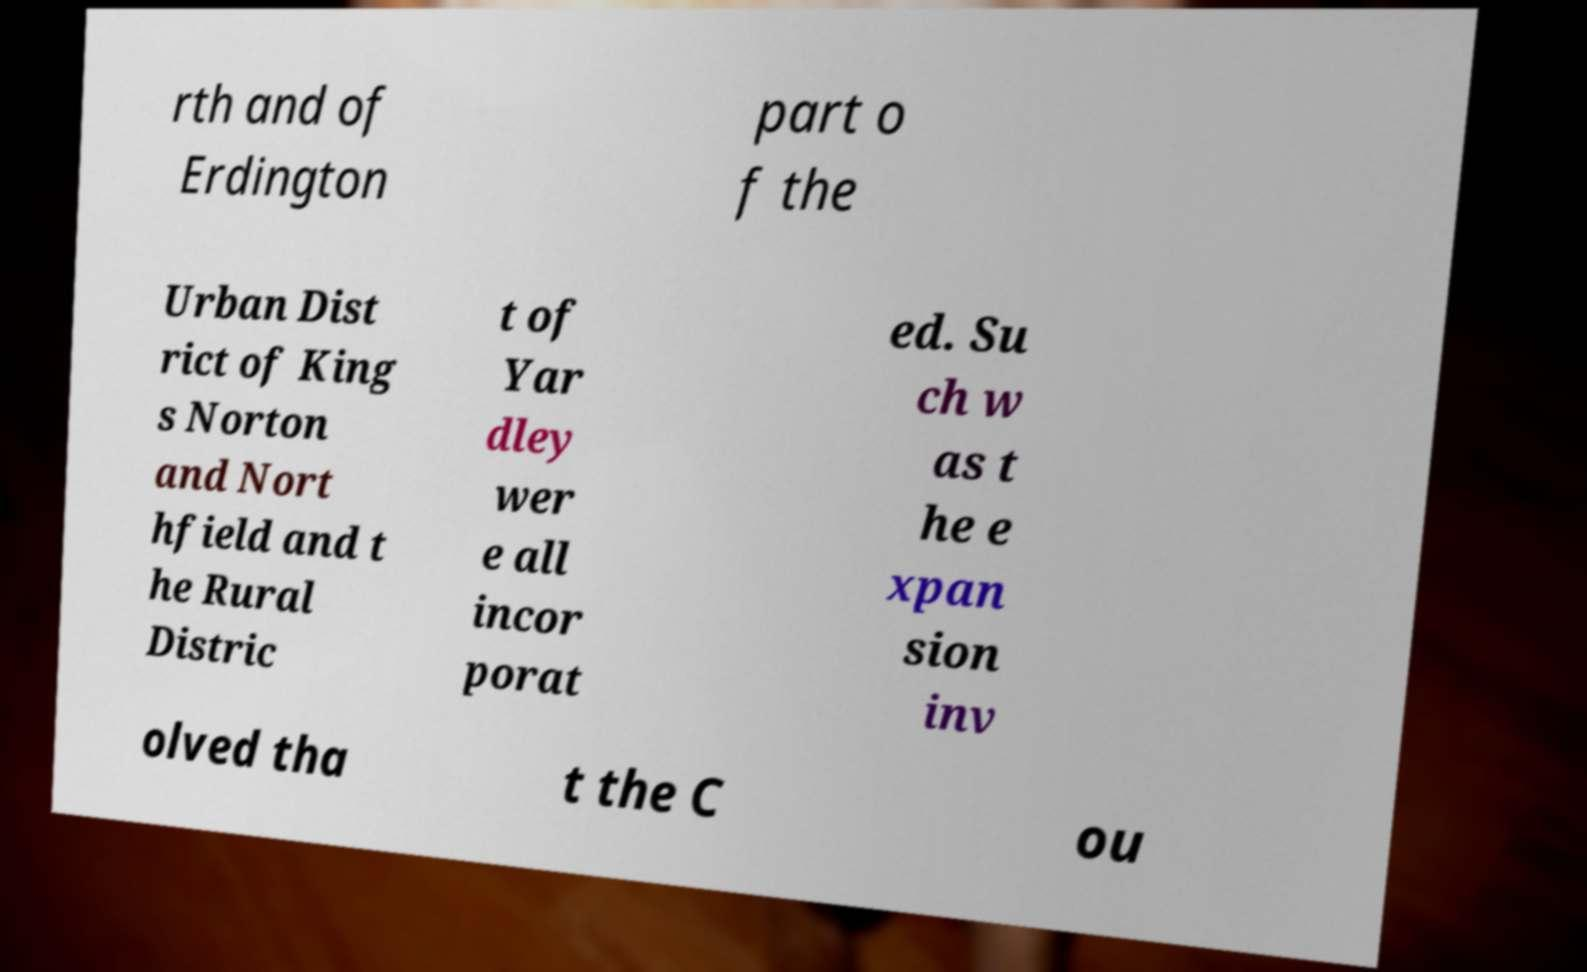I need the written content from this picture converted into text. Can you do that? rth and of Erdington part o f the Urban Dist rict of King s Norton and Nort hfield and t he Rural Distric t of Yar dley wer e all incor porat ed. Su ch w as t he e xpan sion inv olved tha t the C ou 